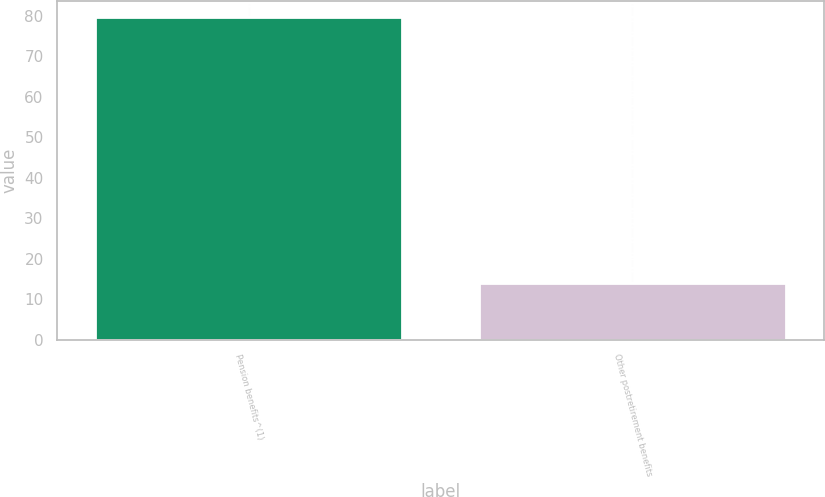Convert chart. <chart><loc_0><loc_0><loc_500><loc_500><bar_chart><fcel>Pension benefits^(1)<fcel>Other postretirement benefits<nl><fcel>79.7<fcel>14<nl></chart> 